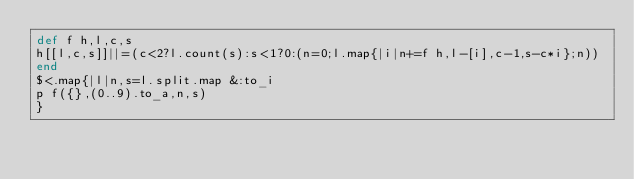<code> <loc_0><loc_0><loc_500><loc_500><_Ruby_>def f h,l,c,s
h[[l,c,s]]||=(c<2?l.count(s):s<1?0:(n=0;l.map{|i|n+=f h,l-[i],c-1,s-c*i};n))
end
$<.map{|l|n,s=l.split.map &:to_i
p f({},(0..9).to_a,n,s)
}</code> 